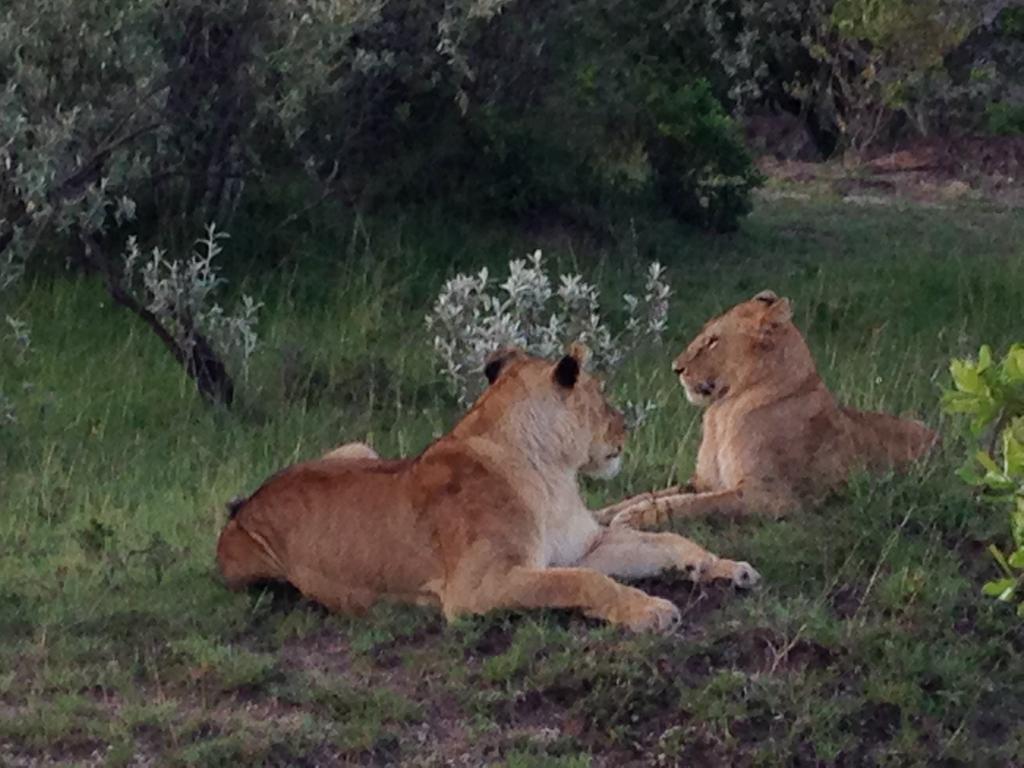In one or two sentences, can you explain what this image depicts? Here I can see two lions and there are many plants and also I can see the grass. In the background there are many trees. 